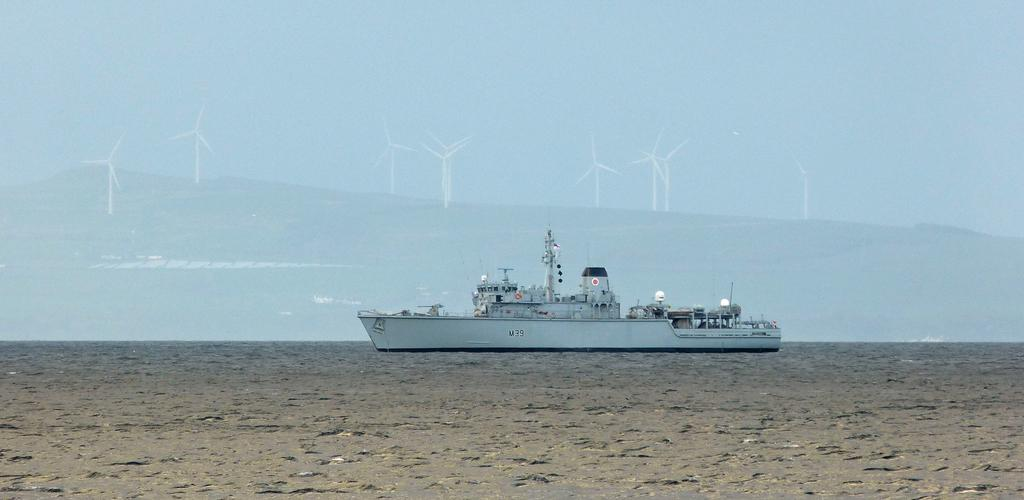What is the main subject of the image? There is a ship in the image. What can be seen in the background of the image? There are windmills in the background of the image. What atmospheric condition is visible in the image? Fog is visible in the image. What type of flower is growing on the ship's deck in the image? There are no flowers visible on the ship's deck in the image. 